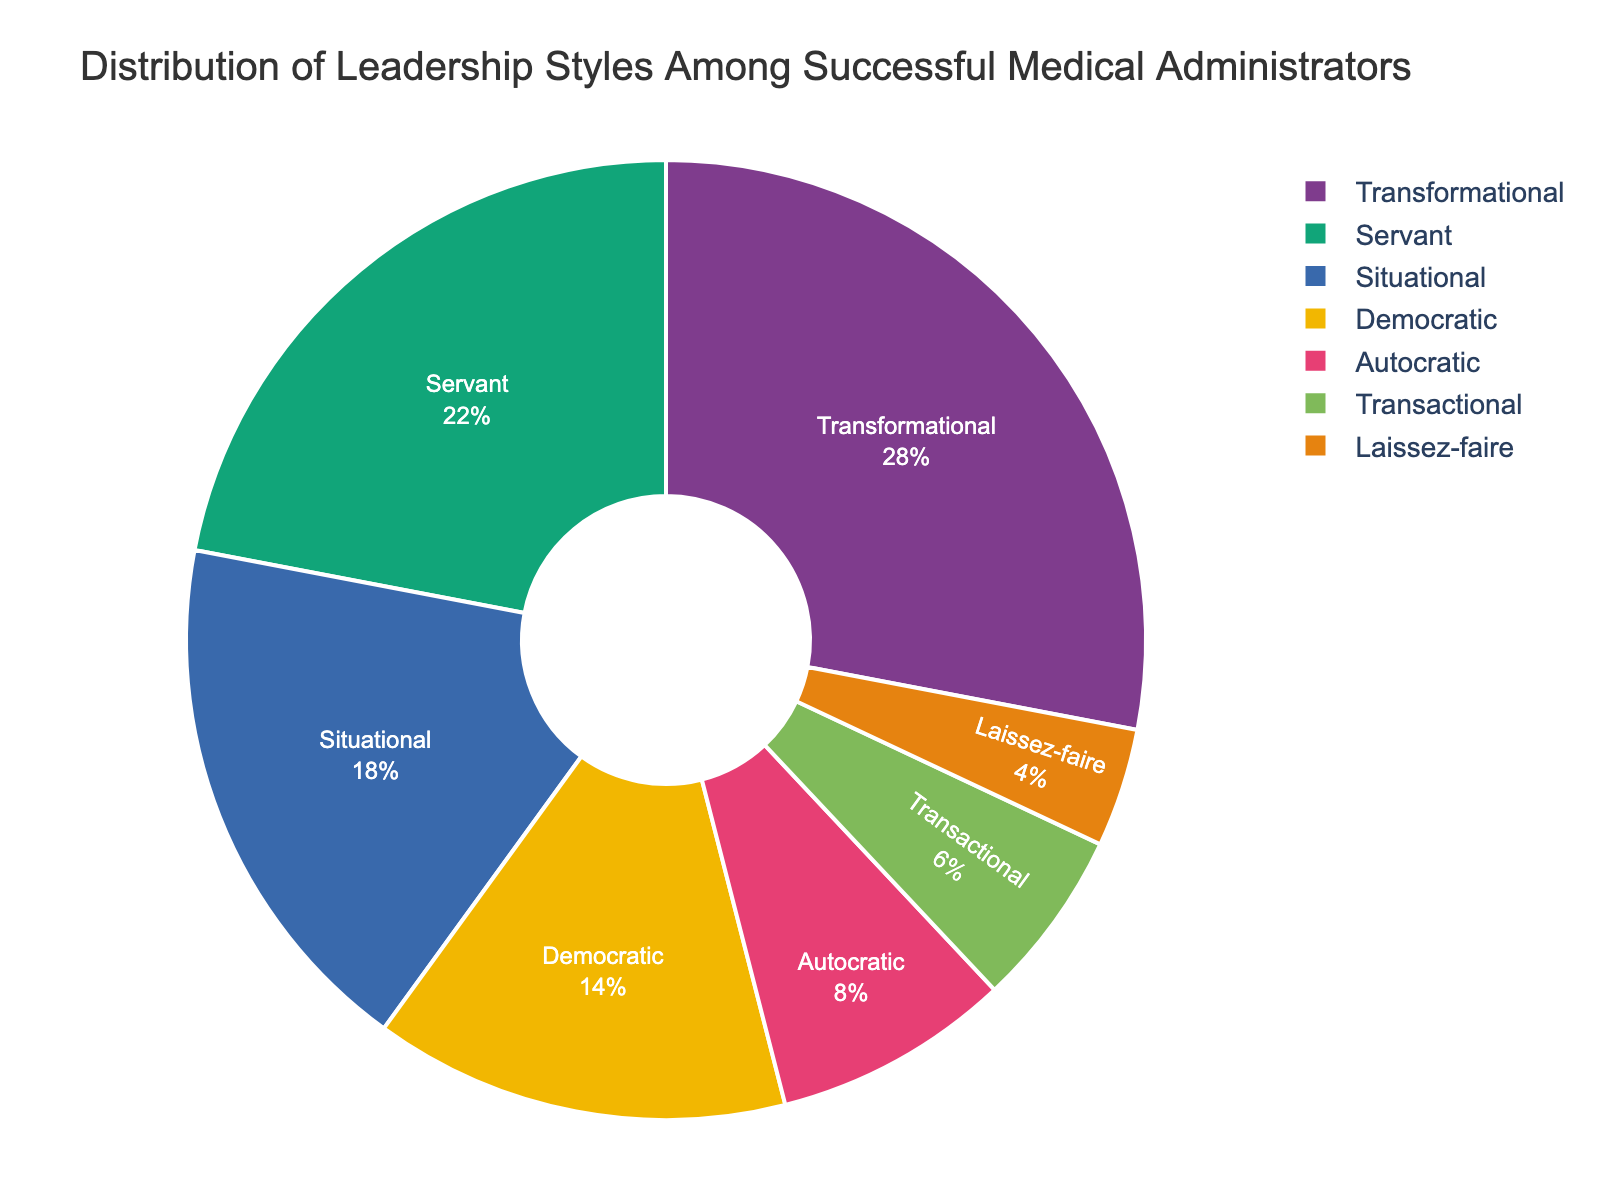What's the most common leadership style among successful medical administrators? The pie chart shows that the largest segment is labeled as "Transformational" with a percentage of 28%. Therefore, Transformational is the most common leadership style.
Answer: Transformational Which two leadership styles are closest in their distribution percentages, and what's their combined percentage? Servant and Situational leadership styles are closest in their distribution percentages, listed at 22% and 18%, respectively. Their combined percentage is 22 + 18 = 40%.
Answer: 40% Is the percentage of Autocratic leadership more or less than half of the Transformational leadership percentage? The Transformational leadership style has a percentage of 28%. Half of that is 14%. The Autocratic leadership style is at 8%, which is less than 14%.
Answer: Less What is the difference in percentage between the Democratic and Transactional leadership styles? The pie chart shows that the Democratic leadership style is 14% and the Transactional leadership style is 6%. The difference is 14 - 6 = 8%.
Answer: 8% Rank the leadership styles from most to least common. By looking at the percentages in the pie chart, the leadership styles can be ranked as follows: Transformational (28%), Servant (22%), Situational (18%), Democratic (14%), Autocratic (8%), Transactional (6%), Laissez-faire (4%).
Answer: Transformational, Servant, Situational, Democratic, Autocratic, Transactional, Laissez-faire What percentage of leadership styles use a participative approach (Democratic and Servant)? The Democratic leadership style has 14%, and the Servant leadership style has 22%. Their combined percentage is 14 + 22 = 36%.
Answer: 36% Which leadership style has the smallest representation, and what is that percentage? According to the pie chart, Laissez-faire has the smallest segment, listed at 4%.
Answer: Laissez-faire Are there any leadership styles that are equally distributed? The pie chart shows no two leadership styles have the same percentage, meaning there are no equally distributed styles.
Answer: No If the percentages of Transformational and Servant leadership styles are combined, do they account for more than half of the total distribution? The Transformational and Servant leadership styles have percentages of 28% and 22%, respectively. Their combined percentage is 28 + 22 = 50%, which equals half the total distribution.
Answer: Yes Divide the leadership styles into two groups: those with percentages above the mean and those below. What are the groups? The mean percentage of all seven leadership styles is (28 + 22 + 18 + 14 + 8 + 6 + 4) / 7 ≈ 14.29%. Styles above the mean are Transformational (28%), Servant (22%), Situational (18%), and Democratic (14%). Styles below the mean are Autocratic (8%), Transactional (6%), and Laissez-faire (4%).
Answer: Above mean: Transformational, Servant, Situational, Democratic; Below mean: Autocratic, Transactional, Laissez-faire 